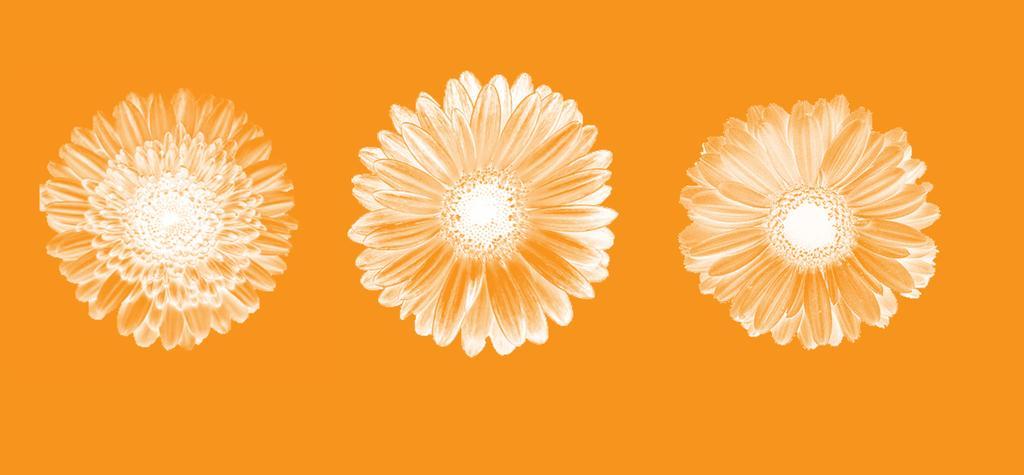Please provide a concise description of this image. As we can see in the image there is drawing of flowers. 